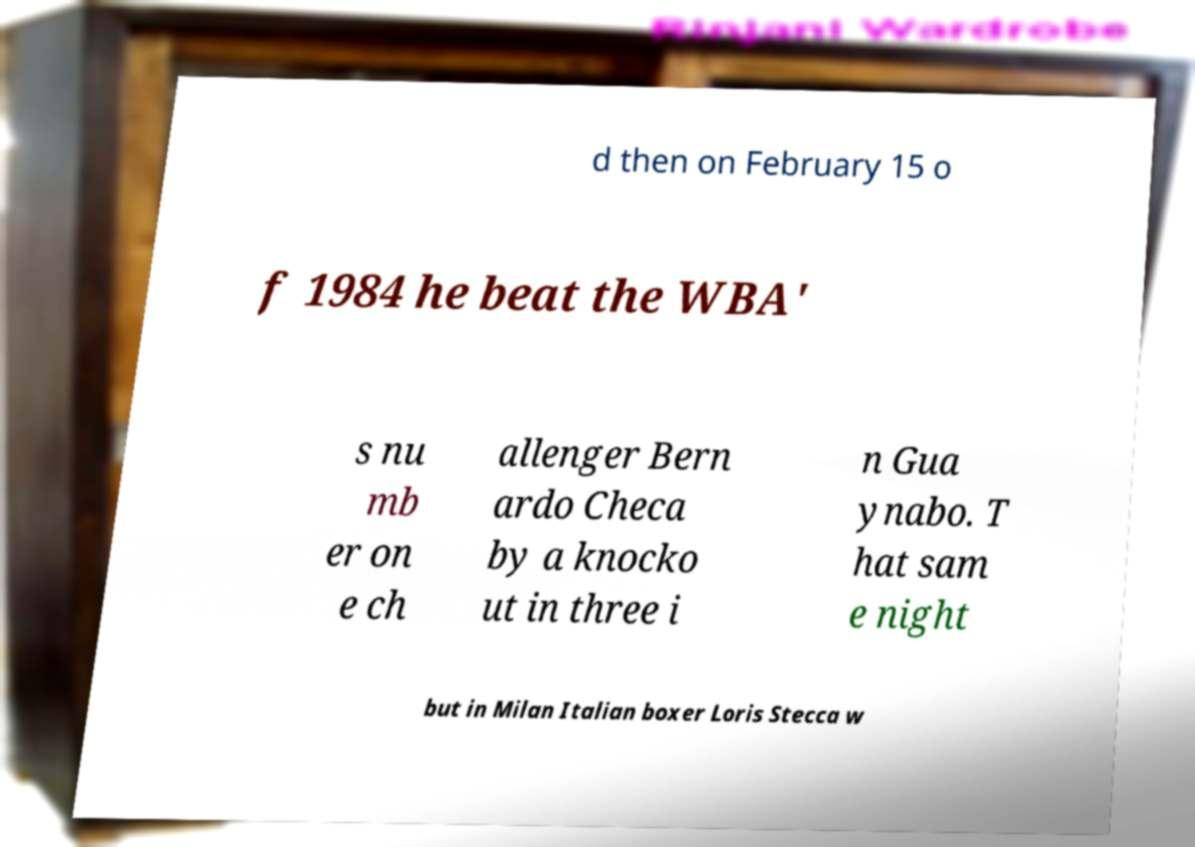Can you accurately transcribe the text from the provided image for me? d then on February 15 o f 1984 he beat the WBA' s nu mb er on e ch allenger Bern ardo Checa by a knocko ut in three i n Gua ynabo. T hat sam e night but in Milan Italian boxer Loris Stecca w 